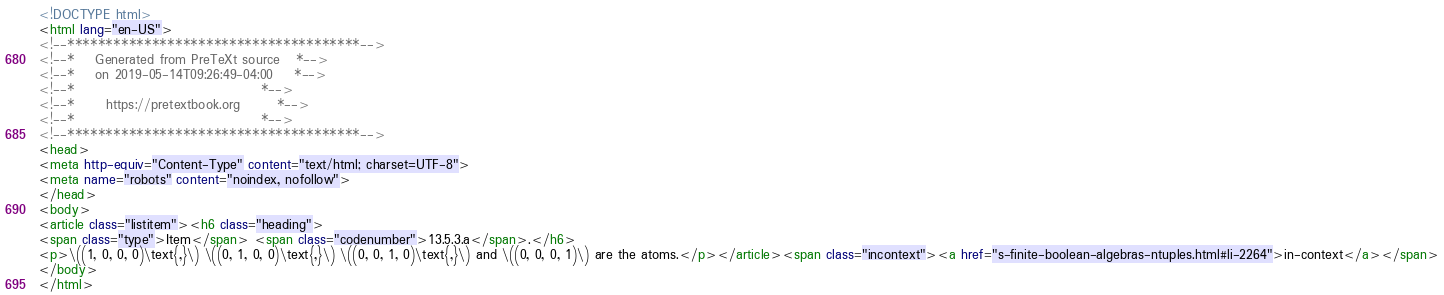<code> <loc_0><loc_0><loc_500><loc_500><_HTML_><!DOCTYPE html>
<html lang="en-US">
<!--**************************************-->
<!--*    Generated from PreTeXt source   *-->
<!--*    on 2019-05-14T09:26:49-04:00    *-->
<!--*                                    *-->
<!--*      https://pretextbook.org       *-->
<!--*                                    *-->
<!--**************************************-->
<head>
<meta http-equiv="Content-Type" content="text/html; charset=UTF-8">
<meta name="robots" content="noindex, nofollow">
</head>
<body>
<article class="listitem"><h6 class="heading">
<span class="type">Item</span> <span class="codenumber">13.5.3.a</span>.</h6>
<p>\((1, 0, 0, 0)\text{,}\) \((0, 1, 0, 0)\text{,}\) \((0, 0, 1, 0)\text{,}\) and \((0, 0, 0, 1)\) are the atoms.</p></article><span class="incontext"><a href="s-finite-boolean-algebras-ntuples.html#li-2264">in-context</a></span>
</body>
</html>
</code> 